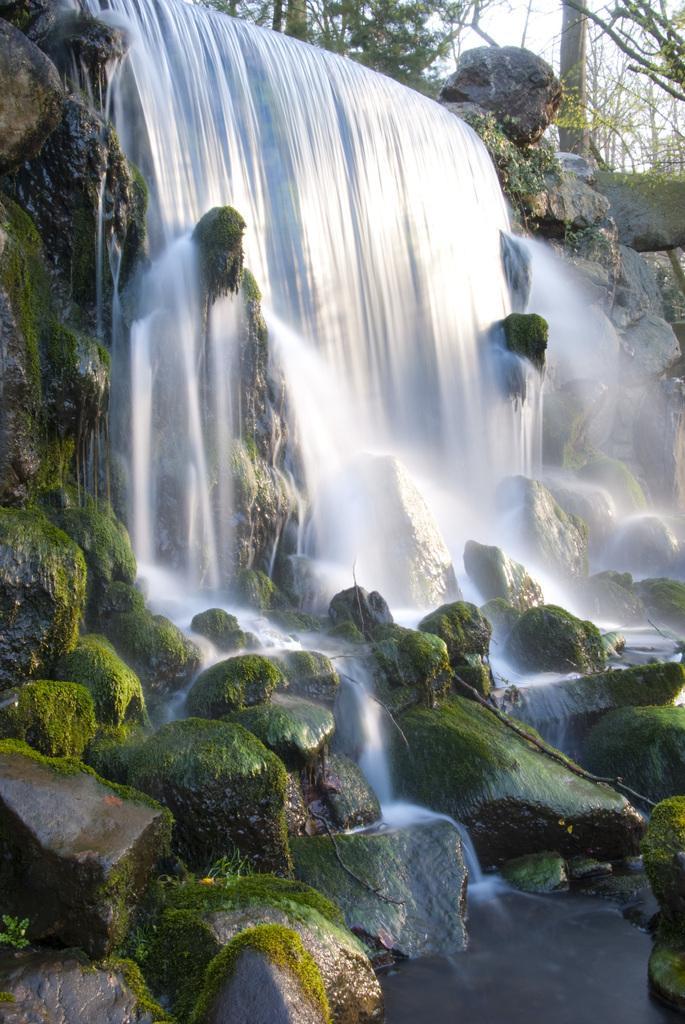Could you give a brief overview of what you see in this image? There is a waterfall on the rocks. In the back there are trees and sky. 